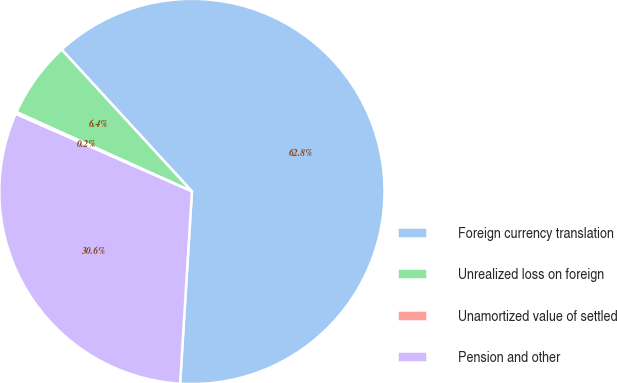Convert chart. <chart><loc_0><loc_0><loc_500><loc_500><pie_chart><fcel>Foreign currency translation<fcel>Unrealized loss on foreign<fcel>Unamortized value of settled<fcel>Pension and other<nl><fcel>62.8%<fcel>6.42%<fcel>0.16%<fcel>30.62%<nl></chart> 